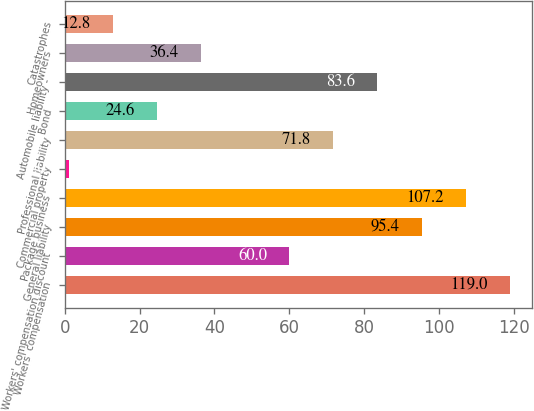Convert chart. <chart><loc_0><loc_0><loc_500><loc_500><bar_chart><fcel>Workers' compensation<fcel>Workers' compensation discount<fcel>General liability<fcel>Package business<fcel>Commercial property<fcel>Professional liability<fcel>Bond<fcel>Automobile liability -<fcel>Homeowners<fcel>Catastrophes<nl><fcel>119<fcel>60<fcel>95.4<fcel>107.2<fcel>1<fcel>71.8<fcel>24.6<fcel>83.6<fcel>36.4<fcel>12.8<nl></chart> 